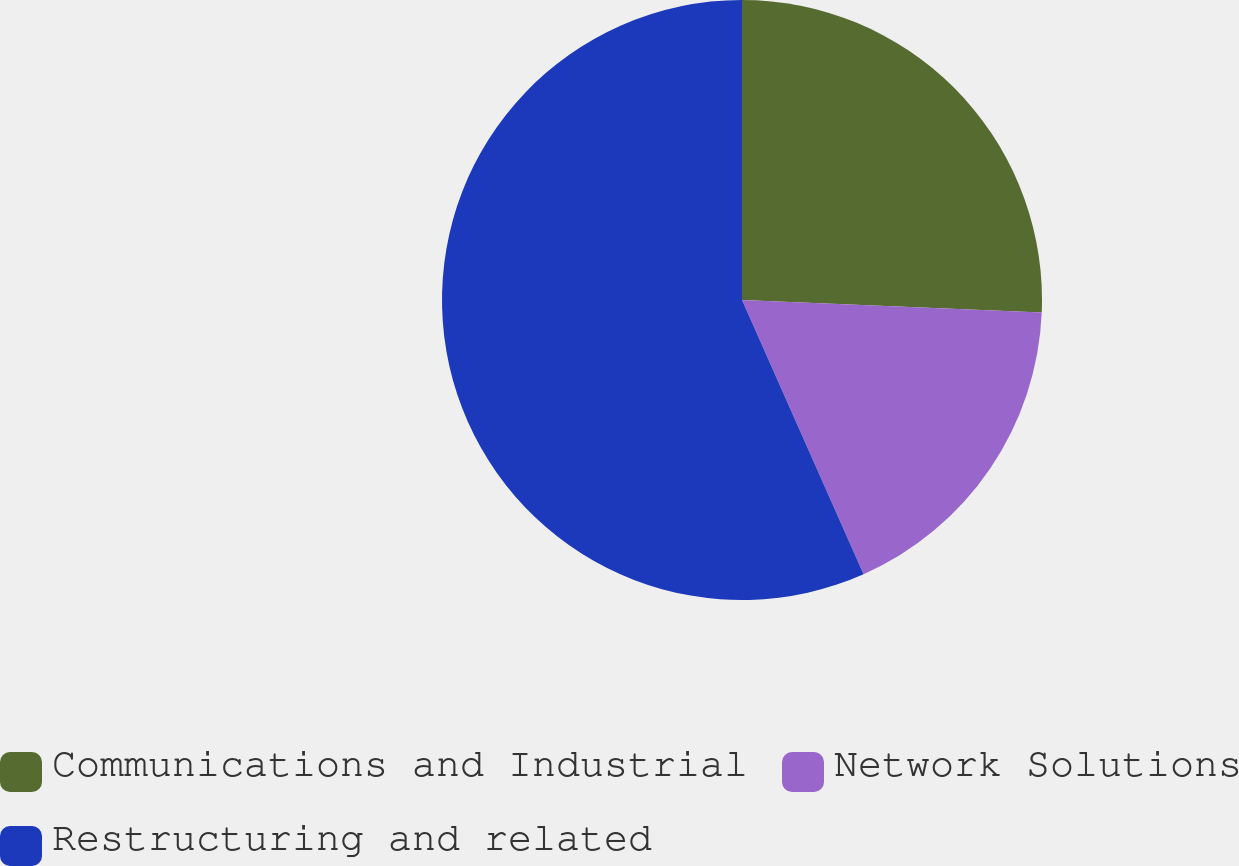<chart> <loc_0><loc_0><loc_500><loc_500><pie_chart><fcel>Communications and Industrial<fcel>Network Solutions<fcel>Restructuring and related<nl><fcel>25.66%<fcel>17.7%<fcel>56.64%<nl></chart> 